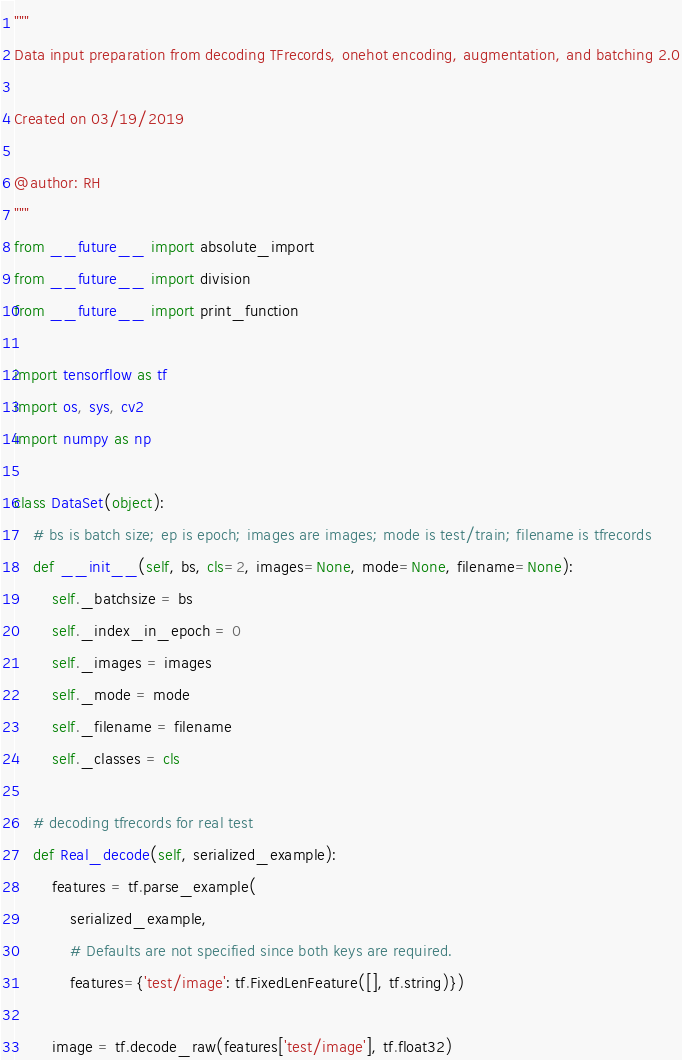<code> <loc_0><loc_0><loc_500><loc_500><_Python_>"""
Data input preparation from decoding TFrecords, onehot encoding, augmentation, and batching 2.0

Created on 03/19/2019

@author: RH
"""
from __future__ import absolute_import
from __future__ import division
from __future__ import print_function

import tensorflow as tf
import os, sys, cv2
import numpy as np

class DataSet(object):
    # bs is batch size; ep is epoch; images are images; mode is test/train; filename is tfrecords
    def __init__(self, bs, cls=2, images=None, mode=None, filename=None):
        self._batchsize = bs
        self._index_in_epoch = 0
        self._images = images
        self._mode = mode
        self._filename = filename
        self._classes = cls

    # decoding tfrecords for real test
    def Real_decode(self, serialized_example):
        features = tf.parse_example(
            serialized_example,
            # Defaults are not specified since both keys are required.
            features={'test/image': tf.FixedLenFeature([], tf.string)})

        image = tf.decode_raw(features['test/image'], tf.float32)</code> 